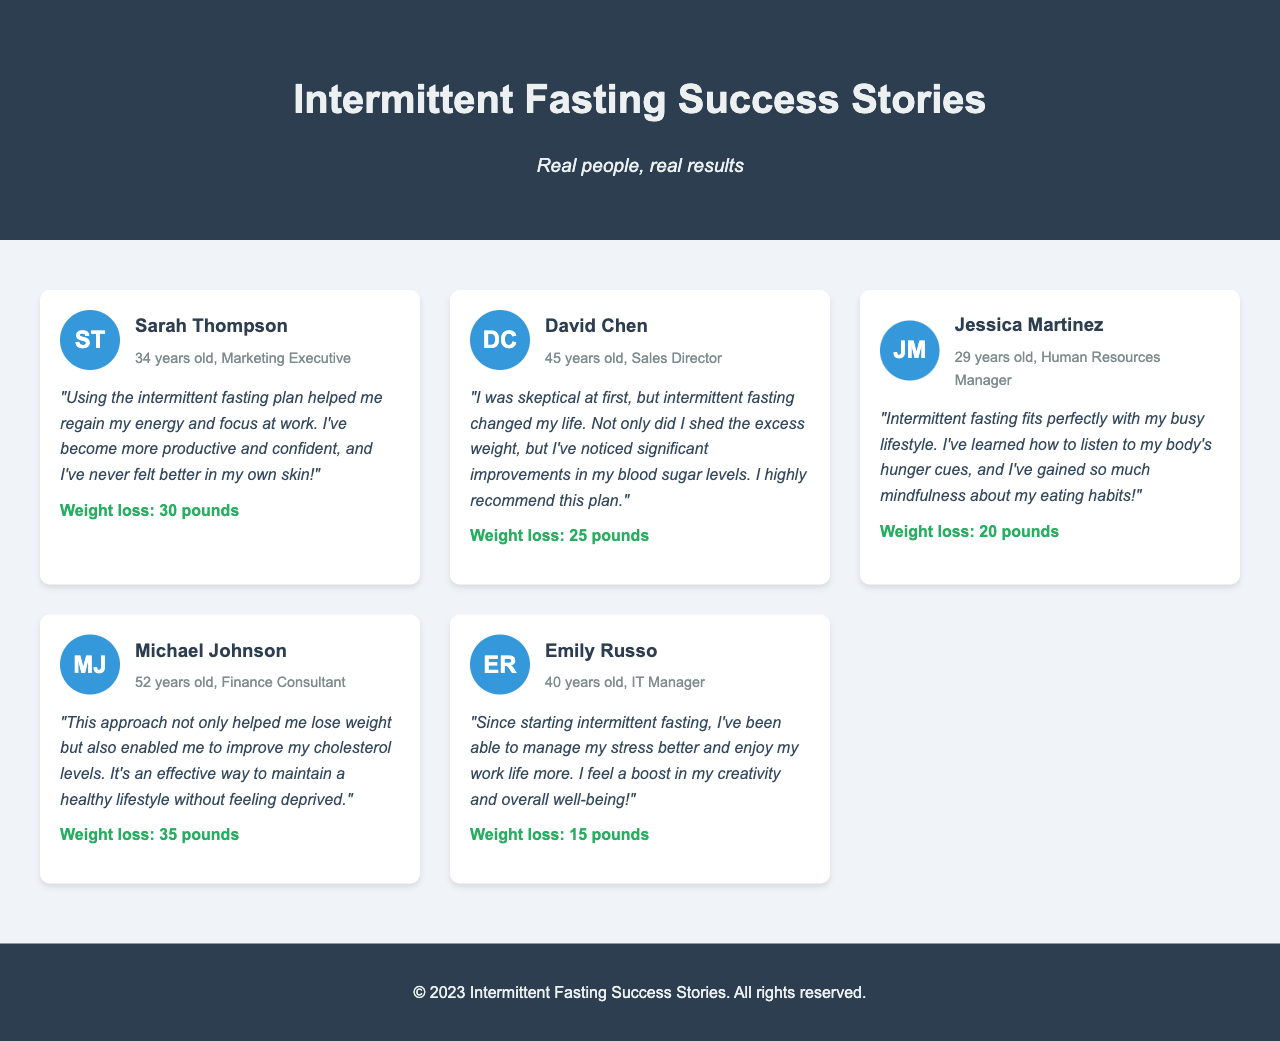What is the title of the document? The title is "Intermittent Fasting Success Stories" as indicated in the header section.
Answer: Intermittent Fasting Success Stories Who is the first testimonial from? The first testimonial is from Sarah Thompson, as shown in the testimonial grid.
Answer: Sarah Thompson How much weight did David Chen lose? David Chen's weight loss is detailed in his testimonial, stating he lost 25 pounds.
Answer: 25 pounds What is Jessica Martinez's occupation? Jessica Martinez is identified as a Human Resources Manager in her information section.
Answer: Human Resources Manager What is the age of Michael Johnson? Michael Johnson's age is mentioned in his testimonial where it states he is 52 years old.
Answer: 52 years old What is a common benefit mentioned by clients in their testimonials? Several testimonials mention improvements in energy levels or productivity as common benefits experienced by clients.
Answer: Energy How many testimonials are displayed in the document? There are five testimonials presented in the testimonial grid section of the document.
Answer: Five Which testimonial includes information about blood sugar levels? David Chen's testimonial includes information about improvements in blood sugar levels following the diet plan.
Answer: David Chen What background color is used for the header? The header has a background color of dark blue (#2c3e50) as described in the style section.
Answer: Dark blue 